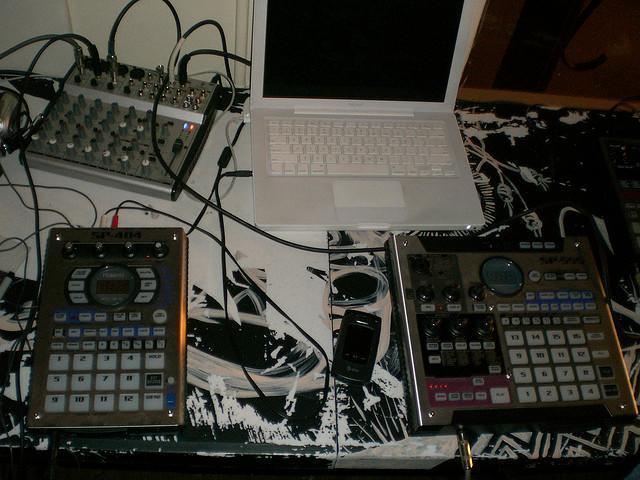How many people are eating food?
Give a very brief answer. 0. 